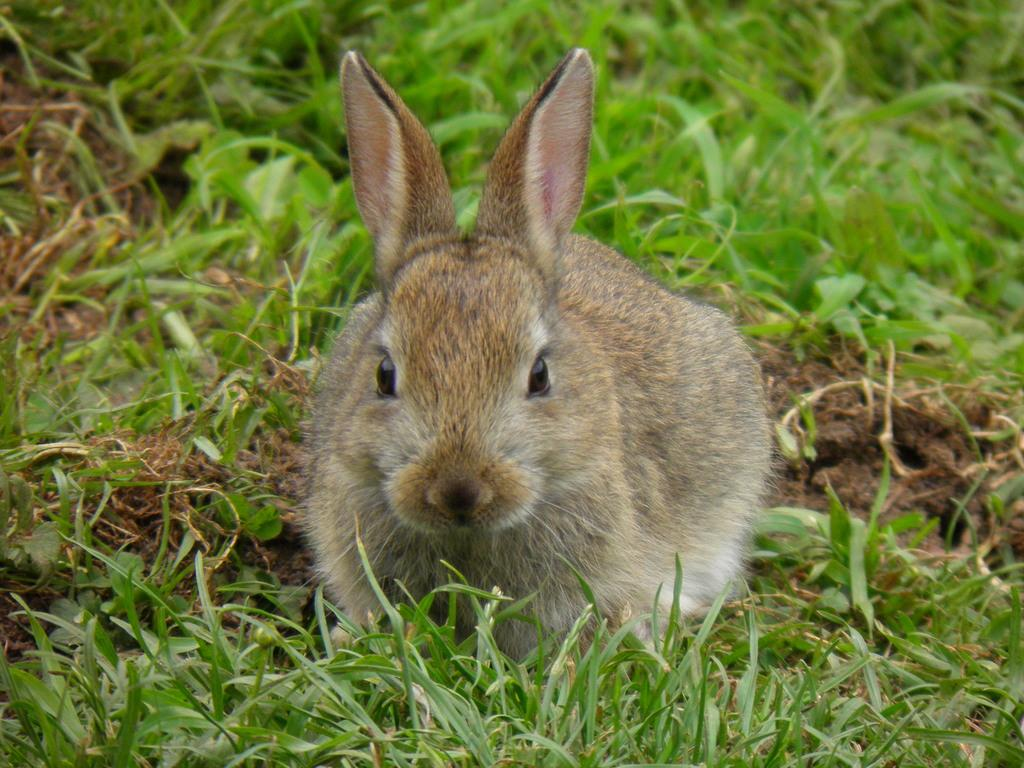What animal is present in the image? There is a rabbit in the image. Where is the rabbit located? The rabbit is on the grass. How many dinosaurs are playing with the rabbit in the image? There are no dinosaurs present in the image; it features a rabbit on the grass. What are the boys doing in the image? There are no boys present in the image; it features a rabbit on the grass. 